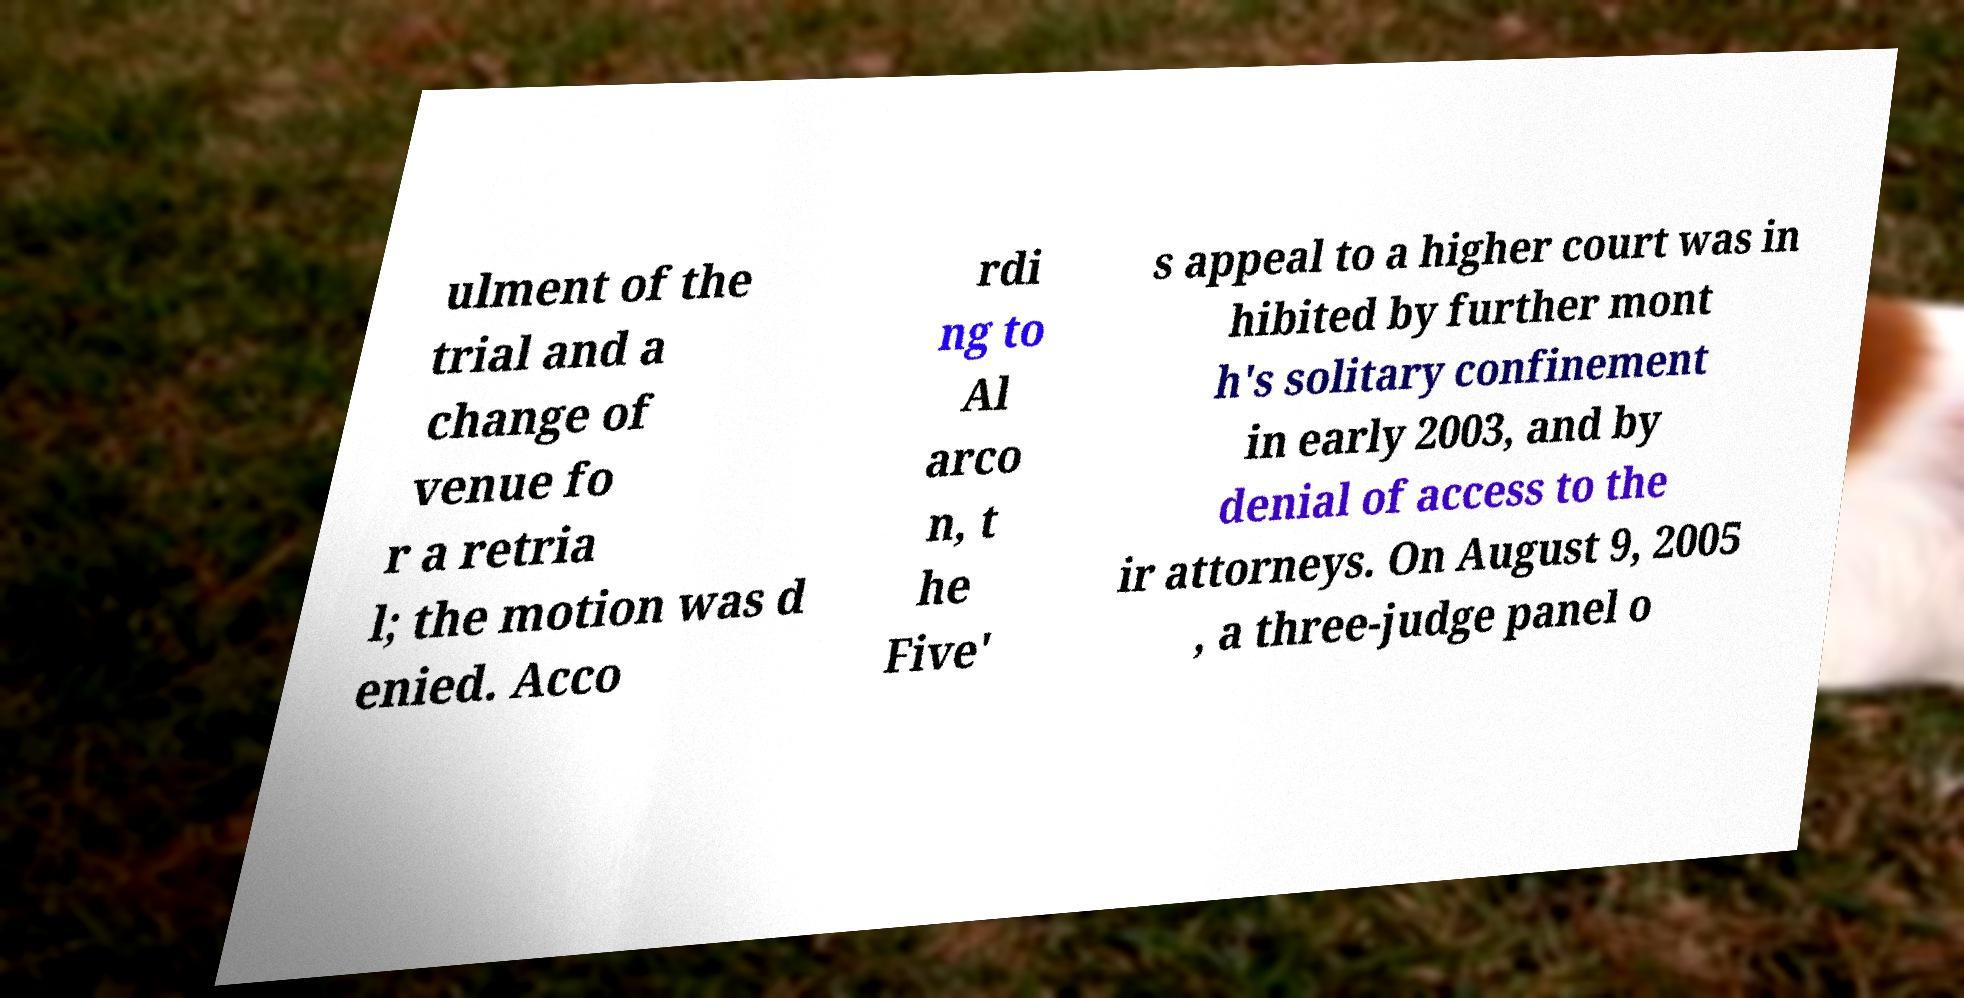Can you read and provide the text displayed in the image?This photo seems to have some interesting text. Can you extract and type it out for me? ulment of the trial and a change of venue fo r a retria l; the motion was d enied. Acco rdi ng to Al arco n, t he Five' s appeal to a higher court was in hibited by further mont h's solitary confinement in early 2003, and by denial of access to the ir attorneys. On August 9, 2005 , a three-judge panel o 